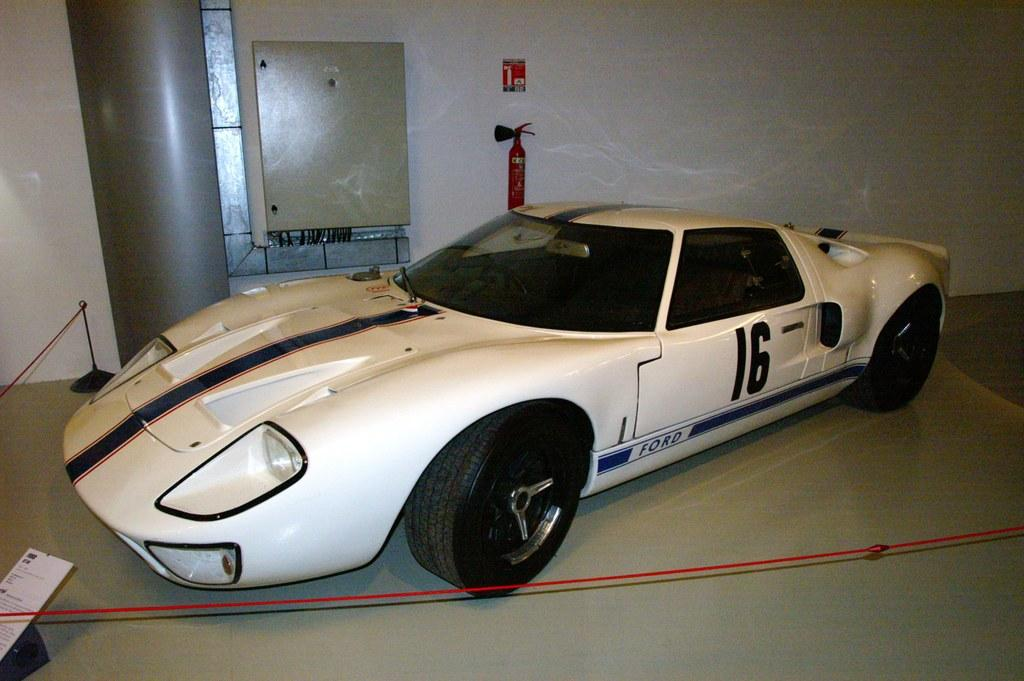What is the main subject of the image? There is a car in the image. Can you describe the color of the car? The car is white. What else can be seen in the background of the image? There is an emergency cylinder in the background of the image. What color is the wall in the background? The wall in the background is white. What type of trousers is the car wearing in the image? Cars do not wear trousers, as they are inanimate objects. --- Facts: 1. There is a group of people in the image. 2. The people are wearing hats. 3. The hats are red. 4. The people are holding hands. 5. There is a tree in the background of the image. Absurd Topics: fish, bicycle, ocean Conversation: What is the main subject of the image? There is a group of people in the image. What are the people wearing on their heads? The people are wearing red hats. What are the people doing in the image? The people are holding hands. What can be seen in the background of the image? There is a tree in the background of the image. Reasoning: Let's think step by step in order to produce the conversation. We start by identifying the main subject of the image, which is the group of people. Then, we describe the hats they are wearing, which are red. Next, we mention the action the people are performing, which is holding hands. Finally, we describe the background of the image, which includes a tree. Absurd Question/Answer: How many fish can be seen swimming in the ocean in the image? There is no ocean or fish present in the image; it features a group of people wearing red hats and holding hands with a tree in the background. 